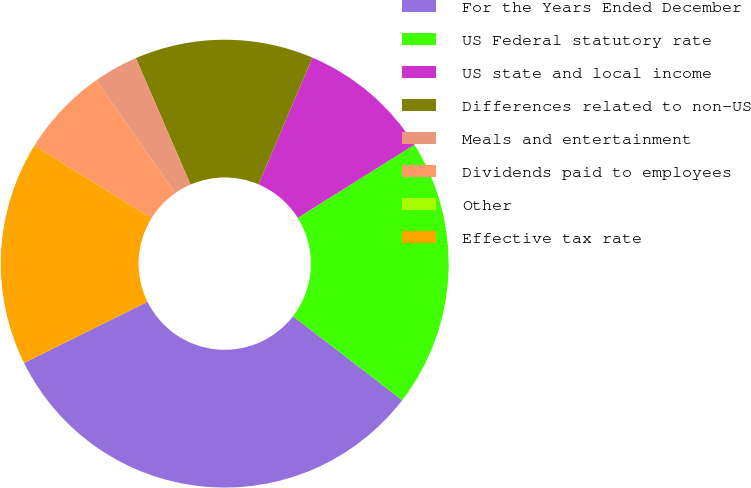<chart> <loc_0><loc_0><loc_500><loc_500><pie_chart><fcel>For the Years Ended December<fcel>US Federal statutory rate<fcel>US state and local income<fcel>Differences related to non-US<fcel>Meals and entertainment<fcel>Dividends paid to employees<fcel>Other<fcel>Effective tax rate<nl><fcel>32.25%<fcel>19.35%<fcel>9.68%<fcel>12.9%<fcel>3.23%<fcel>6.45%<fcel>0.0%<fcel>16.13%<nl></chart> 